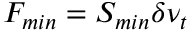<formula> <loc_0><loc_0><loc_500><loc_500>F _ { \min } = S _ { \min } \delta \nu _ { t }</formula> 